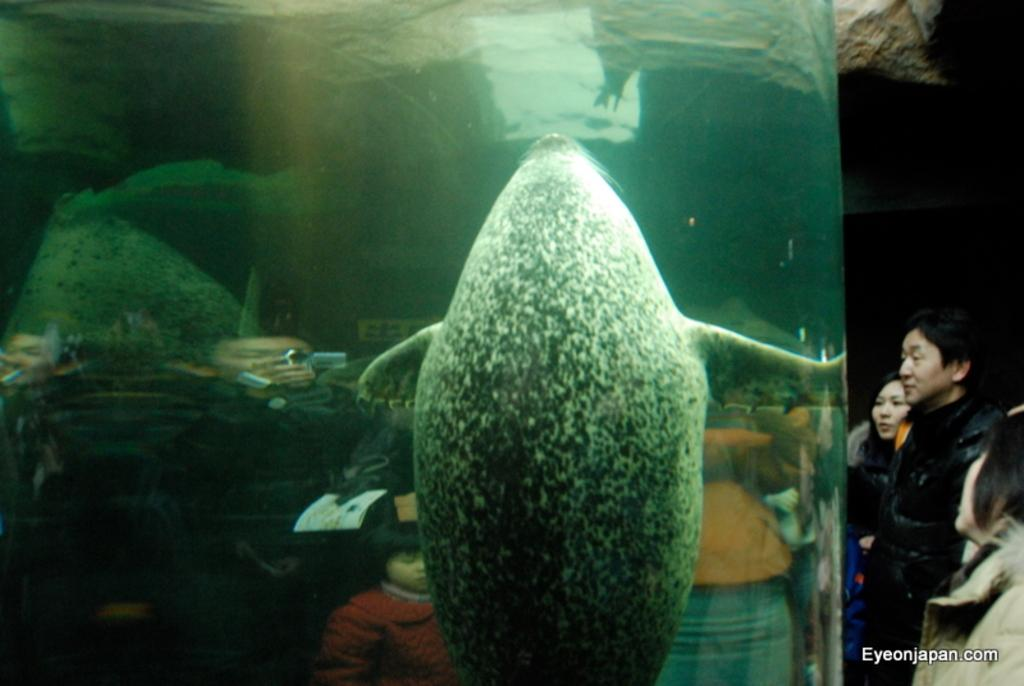What is the animal doing in the water in the image? The animal is in the water, but the specific activity cannot be determined from the provided facts. What is the relationship between the animal and the group of people in the image? The group of people is beside the animal, but their interaction or relationship cannot be determined from the provided facts. Where is the watermark located in the image? The watermark is at the right bottom of the image. What flavor of ice cream is the animal holding in the image? There is no ice cream present in the image, and the animal is not holding anything. What type of creature is the animal in the image? The specific type of animal cannot be determined from the provided facts. 